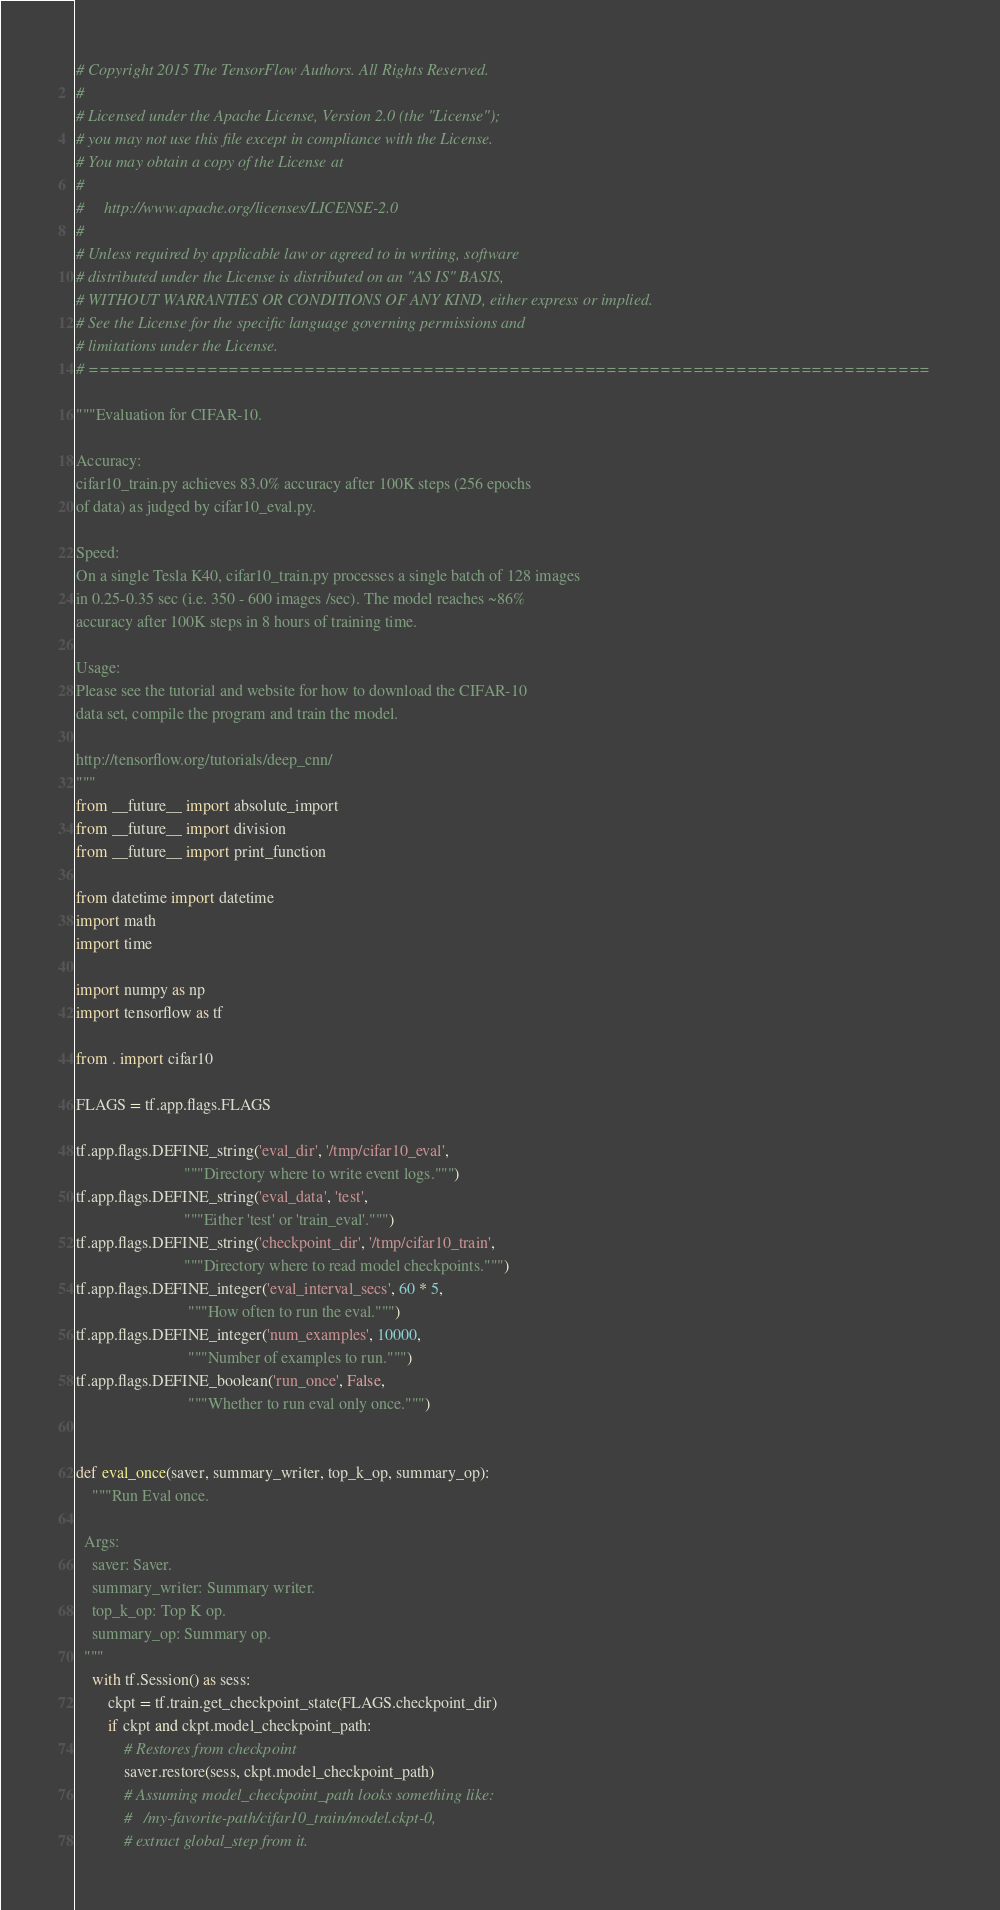Convert code to text. <code><loc_0><loc_0><loc_500><loc_500><_Python_># Copyright 2015 The TensorFlow Authors. All Rights Reserved.
#
# Licensed under the Apache License, Version 2.0 (the "License");
# you may not use this file except in compliance with the License.
# You may obtain a copy of the License at
#
#     http://www.apache.org/licenses/LICENSE-2.0
#
# Unless required by applicable law or agreed to in writing, software
# distributed under the License is distributed on an "AS IS" BASIS,
# WITHOUT WARRANTIES OR CONDITIONS OF ANY KIND, either express or implied.
# See the License for the specific language governing permissions and
# limitations under the License.
# ==============================================================================

"""Evaluation for CIFAR-10.

Accuracy:
cifar10_train.py achieves 83.0% accuracy after 100K steps (256 epochs
of data) as judged by cifar10_eval.py.

Speed:
On a single Tesla K40, cifar10_train.py processes a single batch of 128 images
in 0.25-0.35 sec (i.e. 350 - 600 images /sec). The model reaches ~86%
accuracy after 100K steps in 8 hours of training time.

Usage:
Please see the tutorial and website for how to download the CIFAR-10
data set, compile the program and train the model.

http://tensorflow.org/tutorials/deep_cnn/
"""
from __future__ import absolute_import
from __future__ import division
from __future__ import print_function

from datetime import datetime
import math
import time

import numpy as np
import tensorflow as tf

from . import cifar10

FLAGS = tf.app.flags.FLAGS

tf.app.flags.DEFINE_string('eval_dir', '/tmp/cifar10_eval',
                           """Directory where to write event logs.""")
tf.app.flags.DEFINE_string('eval_data', 'test',
                           """Either 'test' or 'train_eval'.""")
tf.app.flags.DEFINE_string('checkpoint_dir', '/tmp/cifar10_train',
                           """Directory where to read model checkpoints.""")
tf.app.flags.DEFINE_integer('eval_interval_secs', 60 * 5,
                            """How often to run the eval.""")
tf.app.flags.DEFINE_integer('num_examples', 10000,
                            """Number of examples to run.""")
tf.app.flags.DEFINE_boolean('run_once', False,
                            """Whether to run eval only once.""")


def eval_once(saver, summary_writer, top_k_op, summary_op):
    """Run Eval once.

  Args:
    saver: Saver.
    summary_writer: Summary writer.
    top_k_op: Top K op.
    summary_op: Summary op.
  """
    with tf.Session() as sess:
        ckpt = tf.train.get_checkpoint_state(FLAGS.checkpoint_dir)
        if ckpt and ckpt.model_checkpoint_path:
            # Restores from checkpoint
            saver.restore(sess, ckpt.model_checkpoint_path)
            # Assuming model_checkpoint_path looks something like:
            #   /my-favorite-path/cifar10_train/model.ckpt-0,
            # extract global_step from it.</code> 